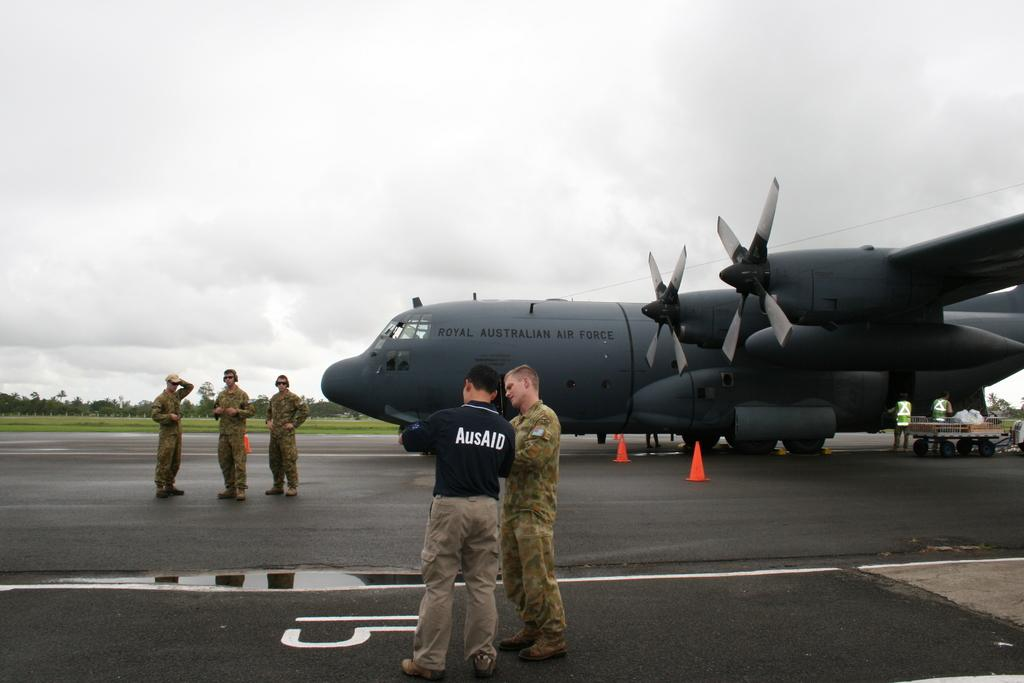<image>
Summarize the visual content of the image. A man is standing in a black shirt with AusAID printed on the back. 